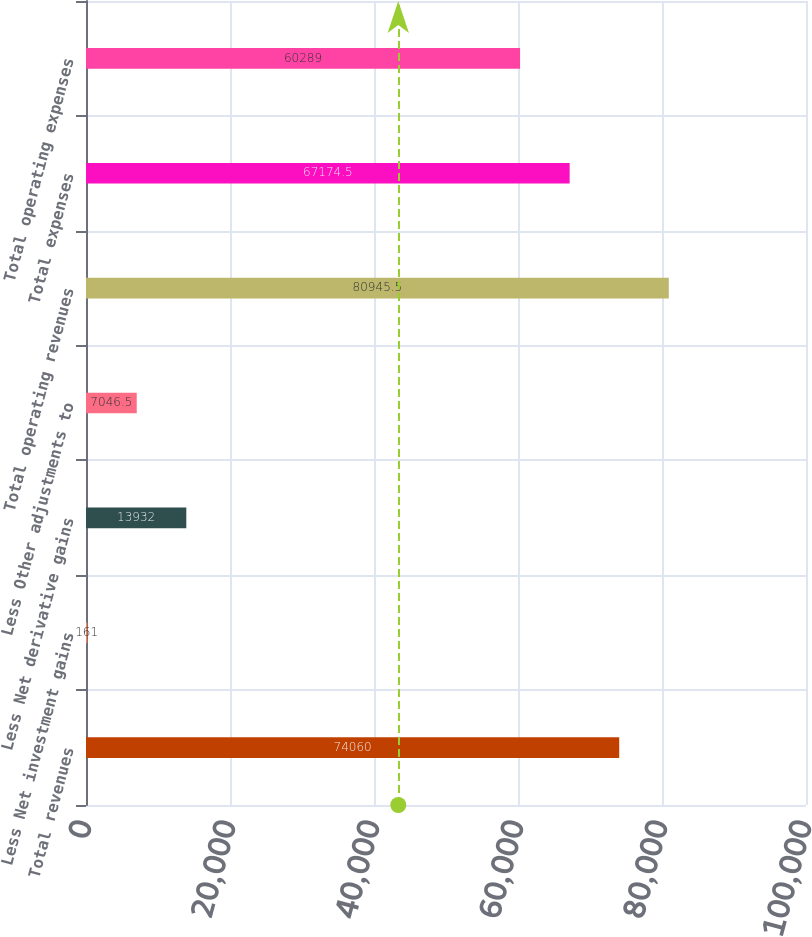Convert chart. <chart><loc_0><loc_0><loc_500><loc_500><bar_chart><fcel>Total revenues<fcel>Less Net investment gains<fcel>Less Net derivative gains<fcel>Less Other adjustments to<fcel>Total operating revenues<fcel>Total expenses<fcel>Total operating expenses<nl><fcel>74060<fcel>161<fcel>13932<fcel>7046.5<fcel>80945.5<fcel>67174.5<fcel>60289<nl></chart> 